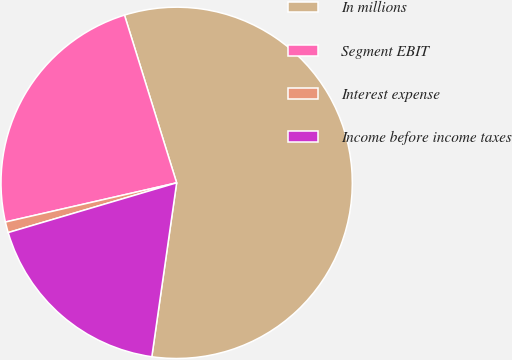Convert chart. <chart><loc_0><loc_0><loc_500><loc_500><pie_chart><fcel>In millions<fcel>Segment EBIT<fcel>Interest expense<fcel>Income before income taxes<nl><fcel>57.05%<fcel>23.78%<fcel>0.99%<fcel>18.17%<nl></chart> 